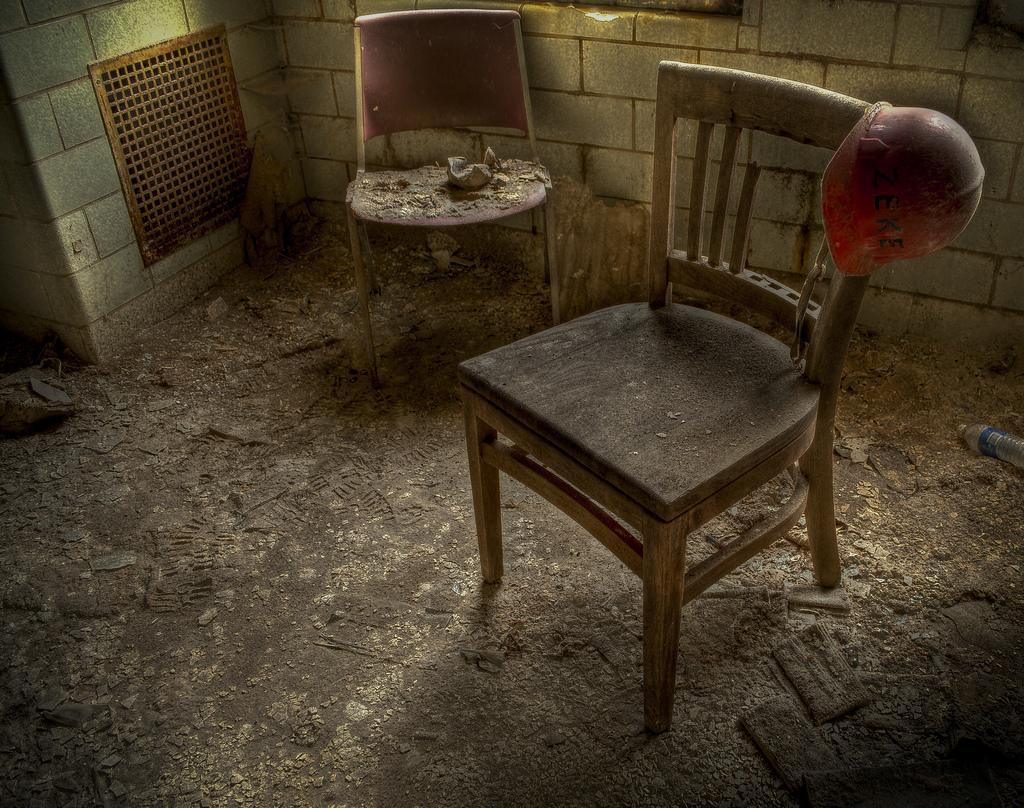Could you give a brief overview of what you see in this image? In front of the image there is a chair. On top of the chair there is some object. Beside the chair there is another chair. In the background of the image there is a wall. At the bottom of the image there is a water bottle and some other objects. 